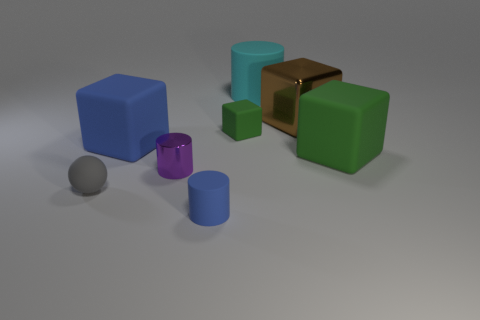What material is the cylinder that is behind the green matte block to the left of the shiny object behind the tiny purple shiny cylinder made of?
Ensure brevity in your answer.  Rubber. What material is the object that is the same color as the tiny matte cylinder?
Offer a terse response. Rubber. Do the block that is right of the brown metal object and the small matte object that is behind the gray sphere have the same color?
Keep it short and to the point. Yes. There is a large object that is behind the big brown object that is behind the green block to the left of the metallic block; what shape is it?
Provide a succinct answer. Cylinder. What shape is the object that is both left of the tiny purple metal thing and in front of the metal cylinder?
Your answer should be very brief. Sphere. There is a shiny object that is in front of the blue thing behind the small purple thing; what number of matte cubes are on the left side of it?
Offer a very short reply. 1. There is a blue matte thing that is the same shape as the big cyan object; what is its size?
Keep it short and to the point. Small. Is the material of the big thing left of the tiny blue cylinder the same as the brown block?
Make the answer very short. No. What is the color of the other large thing that is the same shape as the purple shiny object?
Offer a terse response. Cyan. What number of other objects are the same color as the small rubber cylinder?
Provide a short and direct response. 1. 